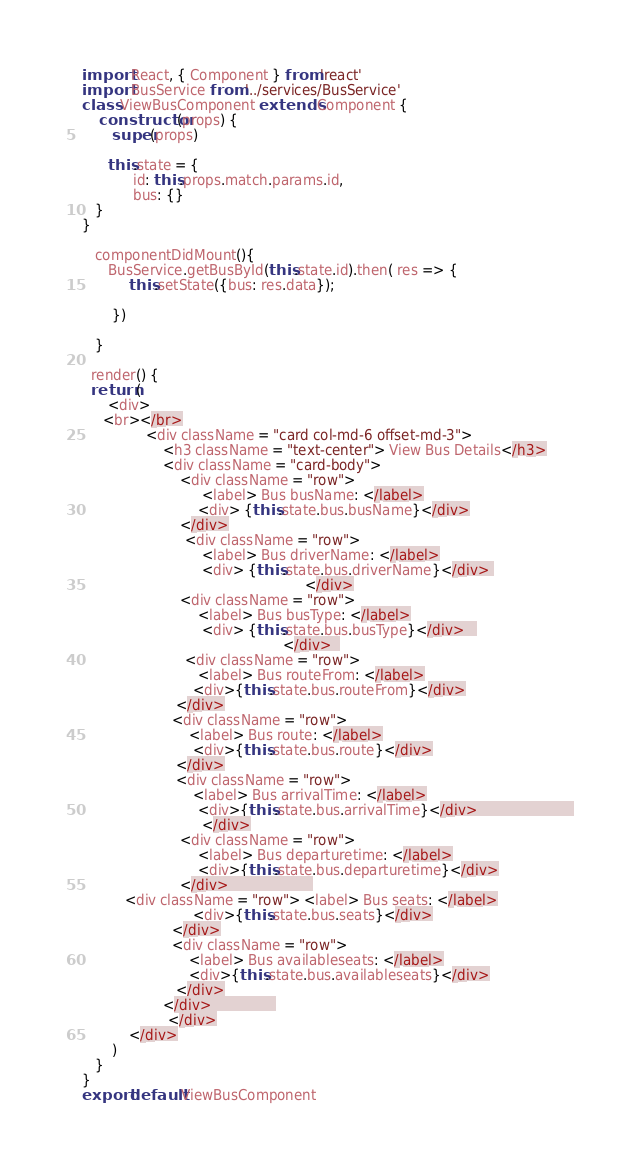<code> <loc_0><loc_0><loc_500><loc_500><_JavaScript_>import React, { Component } from 'react'
import BusService from '../services/BusService'
class ViewBusComponent extends Component {
    constructor(props) {
       super(props)

      this.state = {
            id: this.props.match.params.id,            
            bus: {}      
   }
}

   componentDidMount(){
      BusService.getBusById(this.state.id).then( res => {
           this.setState({bus: res.data});
          
       })
       
   }

  render() {     
  return ( 
      <div>            
     <br></br>
               <div className = "card col-md-6 offset-md-3">
                   <h3 className = "text-center"> View Bus Details</h3>
                   <div className = "card-body">
                       <div className = "row">
                            <label> Bus busName: </label>
                           <div> {this.state.bus.busName}</div>
                       </div>
                        <div className = "row">
                            <label> Bus driverName: </label>
                            <div> {this.state.bus.driverName}</div> 
                                                    </div>
                       <div className = "row">
                           <label> Bus busType: </label>
                            <div> {this.state.bus.busType}</div>   
                                               </div>  
                        <div className = "row">
                           <label> Bus routeFrom: </label>
                          <div>{this.state.bus.routeFrom}</div>
                      </div>
                     <div className = "row">
                         <label> Bus route: </label>
                          <div>{this.state.bus.route}</div>
                      </div>
                      <div className = "row">
                          <label> Bus arrivalTime: </label>
                           <div>{this.state.bus.arrivalTime}</div>                        
                            </div>
                       <div className = "row">
                           <label> Bus departuretime: </label>
                           <div>{this.state.bus.departuretime}</div>
                       </div>                     
          <div className = "row"> <label> Bus seats: </label>
                          <div>{this.state.bus.seats}</div>
                     </div>
                     <div className = "row">
                         <label> Bus availableseats: </label>
                         <div>{this.state.bus.availableseats}</div>
                      </div>
                   </div>                
                    </div>
           </div>
       )
   }
}
export default ViewBusComponent
</code> 